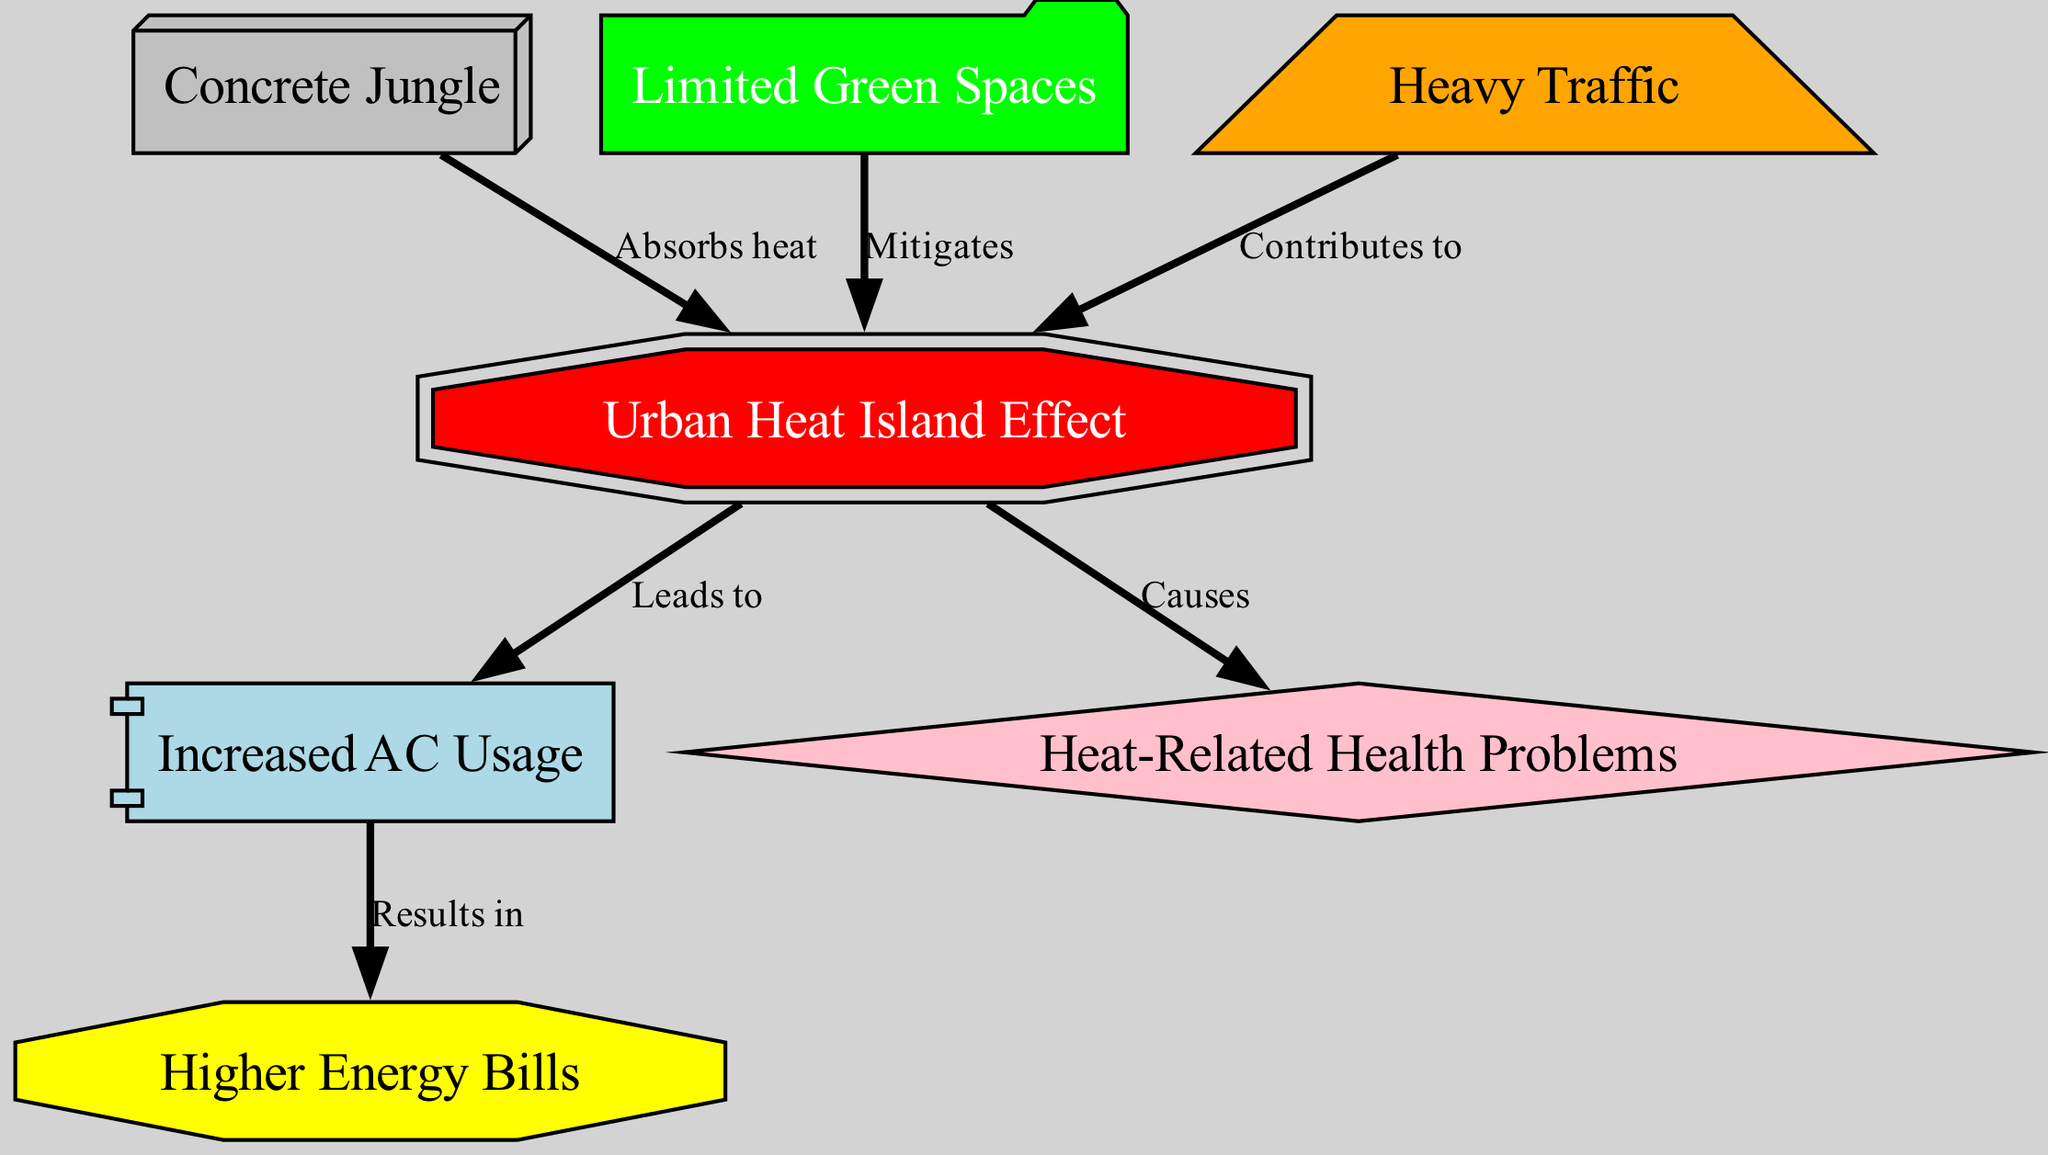What is the main effect depicted in the diagram? The main effect depicted in the diagram is the Urban Heat Island Effect, represented by the central node labeled "Urban Heat Island Effect." This node connects to various other factors that illustrate its causes and consequences.
Answer: Urban Heat Island Effect How many nodes are there in total? The diagram contains a total of seven nodes, including the main effect and related factors. Each node represents a distinct concept or element associated with the Urban Heat Island Effect.
Answer: Seven Which factors contribute to the Urban Heat Island Effect? The contributing factors identified in the diagram are "Concrete Jungle" and "Traffic." The arrows show that these elements either absorb heat or contribute to the heat buildup in urban areas.
Answer: Concrete Jungle, Traffic What effect does the Urban Heat Island lead to? The Urban Heat Island leads to increased air conditioning usage, as indicated by the arrow pointing from "Urban Heat Island Effect" to "Increased AC Usage." This relationship highlights a direct consequence of the heat buildup.
Answer: Increased AC Usage What mitigates the Urban Heat Island Effect according to the diagram? "Limited Green Spaces" mitigates the Urban Heat Island Effect as shown by the arrow going from "Limited Green Spaces" to the "Urban Heat Island Effect." This indicates that green areas help reduce heat in urban environments.
Answer: Limited Green Spaces What are the health problems caused by the Urban Heat Island Effect? The Urban Heat Island Effect causes heat-related health problems, as represented by the connection from "Urban Heat Island Effect" to "Heat-Related Health Problems." This highlights a significant impact of urban heat on public health.
Answer: Heat-Related Health Problems What does increased air conditioning usage result in? Increased air conditioning usage results in higher energy bills, as shown by the connection going from "Increased AC Usage" to "Higher Energy Bills." This reflects the financial implications of coping with urban heat.
Answer: Higher Energy Bills What shape represents the Urban Heat Island Effect in the diagram? The Urban Heat Island Effect is represented in a shape called "doubleoctagon," which visually distinguishes it from other elements in the diagram. This unique shape signifies its importance in the overall context.
Answer: Doubleoctagon 